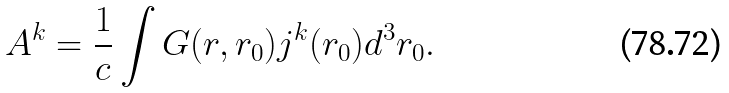Convert formula to latex. <formula><loc_0><loc_0><loc_500><loc_500>A ^ { k } = \frac { 1 } { c } \int G ( r , r _ { 0 } ) j ^ { k } ( r _ { 0 } ) d ^ { 3 } r _ { 0 } .</formula> 